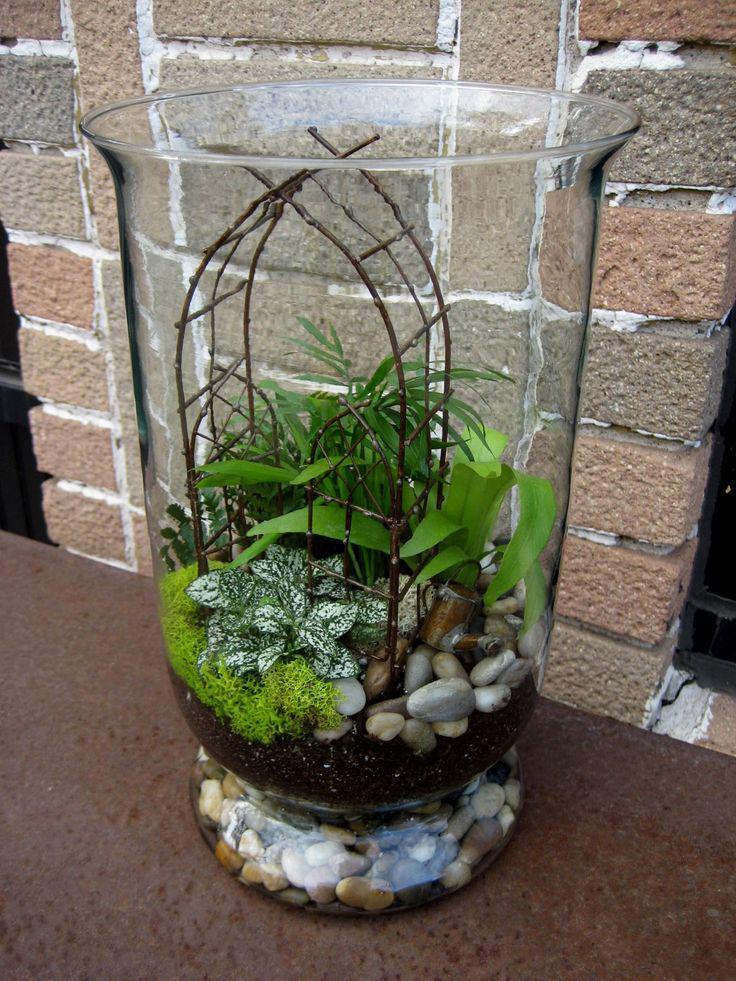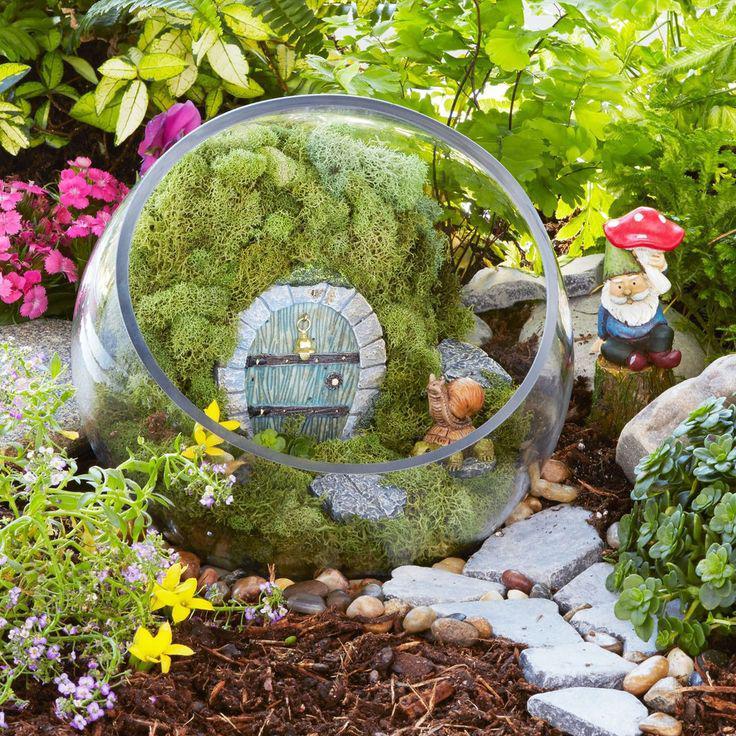The first image is the image on the left, the second image is the image on the right. Analyze the images presented: Is the assertion "The right image features a 'fairy garden' terrarium shaped like a fishbowl on its side." valid? Answer yes or no. Yes. The first image is the image on the left, the second image is the image on the right. For the images shown, is this caption "In at least on image there is a glass container holding a single sitting female fairy with wings." true? Answer yes or no. No. 